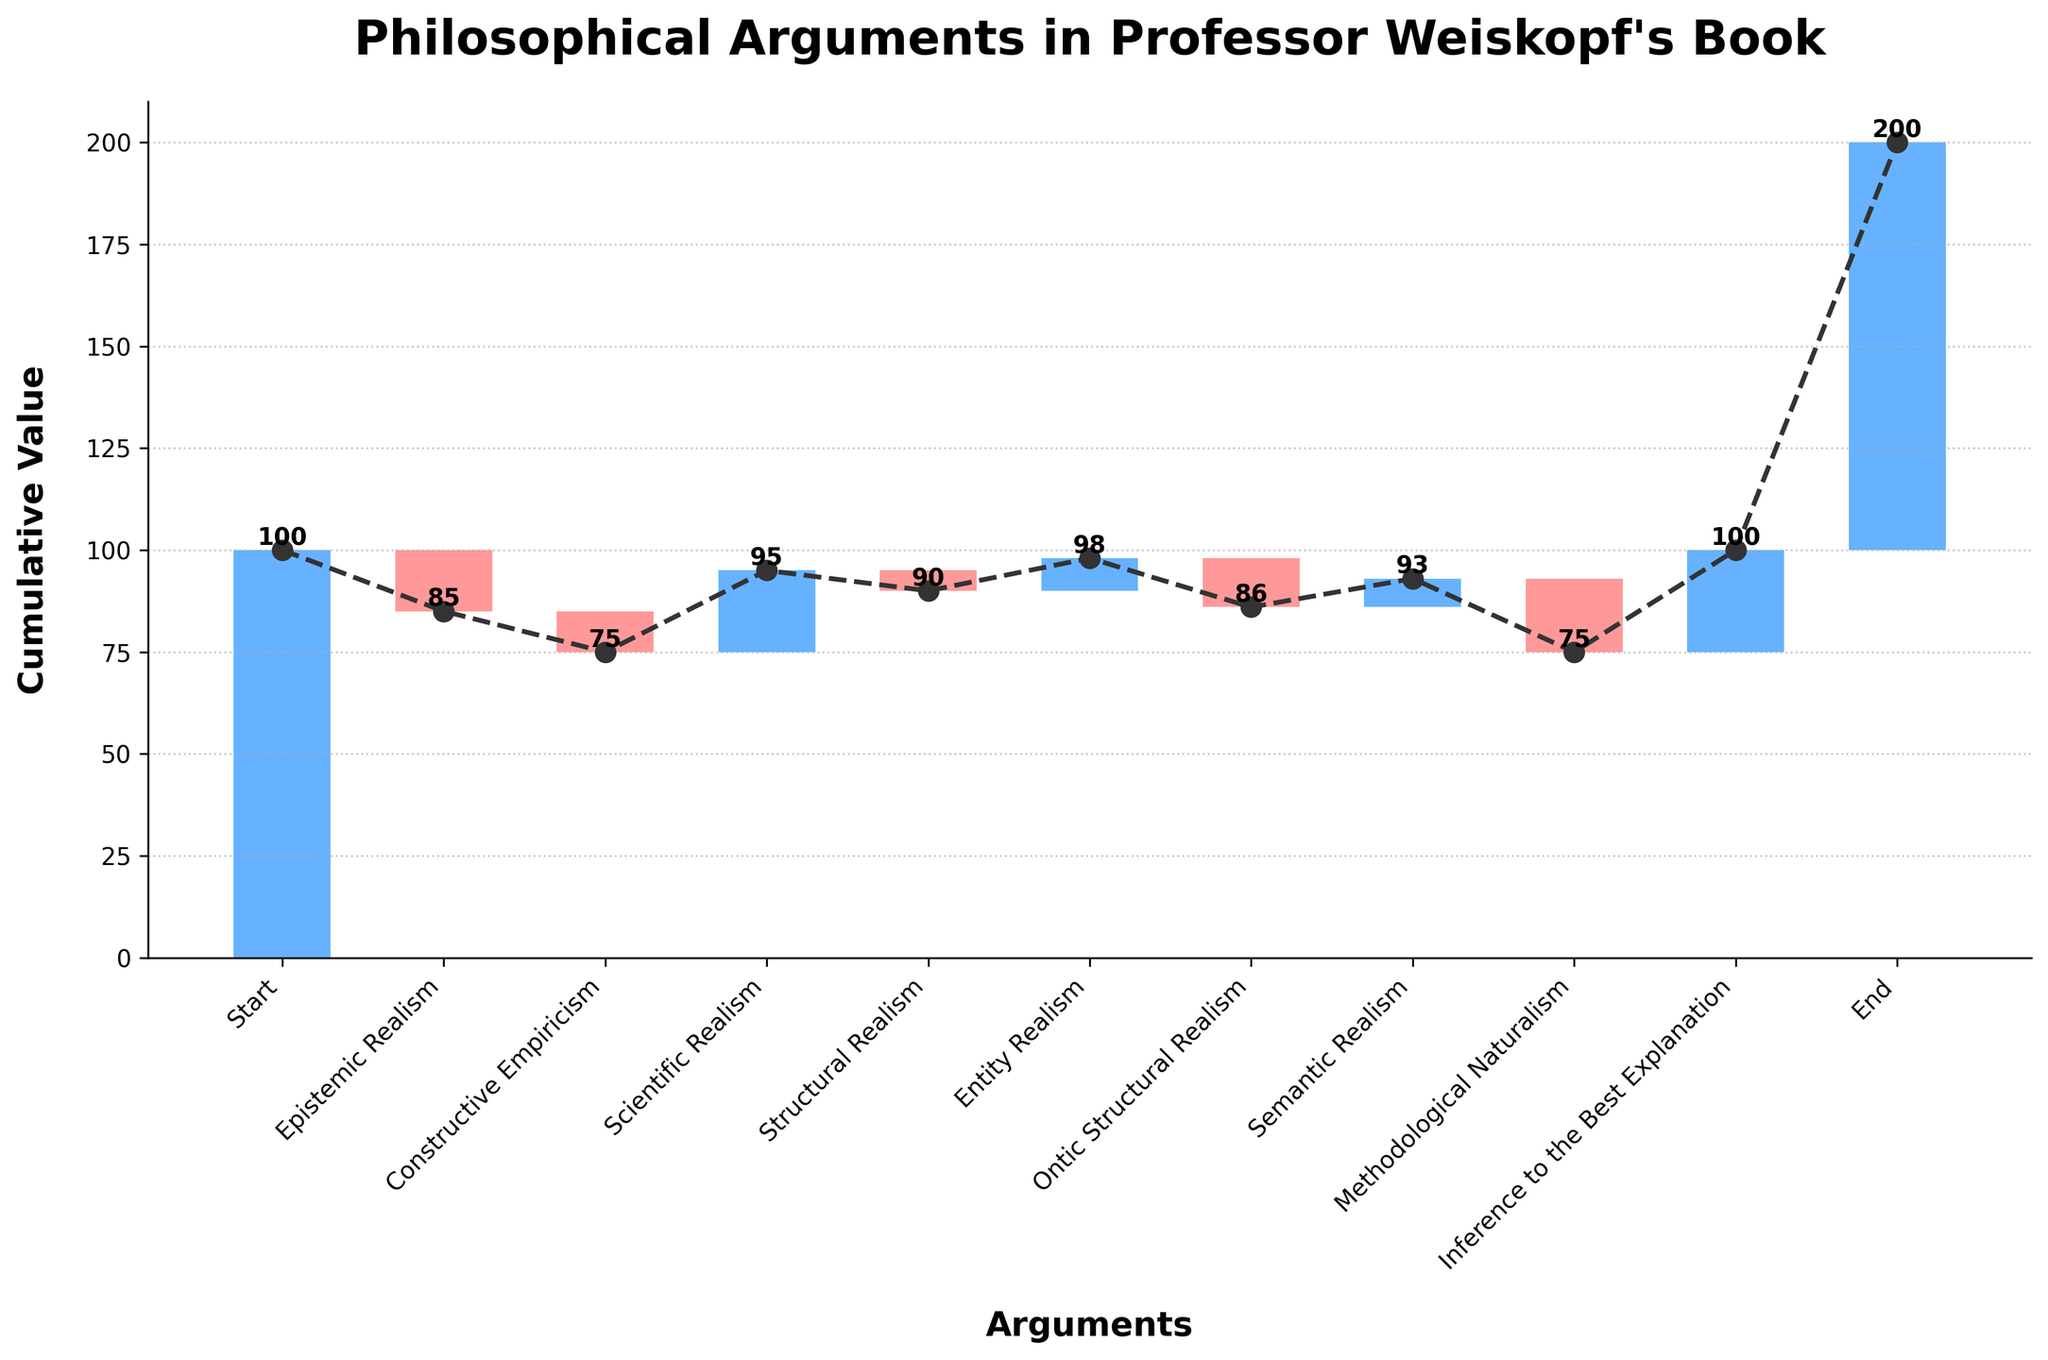what's the title of the figure? The title is displayed at the top of the figure and reads "Philosophical Arguments in Professor Weiskopf's Book."
Answer: Philosophical Arguments in Professor Weiskopf's Book how many arguments are displayed in the figure? By counting the labels on the x-axis, we see there are 10 arguments in total.
Answer: 10 which argument contributes the most positively? The bar for "Inference to the Best Explanation" is the tallest among positive values, indicating it contributes the most positively.
Answer: Inference to the Best Explanation which argument has the most negative impact? The bar representing "Methodological Naturalism" is the longest among negative values, indicating it has the most negative impact.
Answer: Methodological Naturalism what's the cumulative value after "Structural Realism"? Start with the initial value 100, then sum the first five values: 100 - 15 - 10 + 20 - 5 = 90.
Answer: 90 how many arguments contribute negatively? By counting the bars that are colored differently to indicate negative values, there are 4 negative contributions ("Epistemic Realism," "Constructive Empiricism," "Structural Realism," and "Methodological Naturalism").
Answer: 4 which arguments' impacts are exactly equal in magnitude but opposite in sign? "Epistemic Realism" and "Semantic Realism" have equal impacts but in opposite directions, as both have an absolute value of 15 (15 positive and 15 negative respectively).
Answer: Epistemic Realism and Semantic Realism what are the cumulative value changes after "Inference to the Best Explanation"? From the cumulative value after "Methodological Naturalism" (58), add the value from "Inference to the Best Explanation" (+25) to get the new cumulative value: 58 + 25 = 83.
Answer: 83 compare the cumulative values between "Scientific Realism" and "Ontic Structural Realism" After "Scientific Realism," the cumulative value is calculated as 100 - 15 - 10 + 20 = 95. Following "Ontic Structural Realism," the cumulative value is 100 - 15 - 10 + 20 - 5 + 8 - 12 = 86. So, the value difference is 95 - 86 = 9.
Answer: "Scientific Realism" is higher by 9 what color represents the bars with negative impacts? Observing the color scheme, bars with negative impacts are colored red, and this is visually evident for bars representing negative values.
Answer: red 